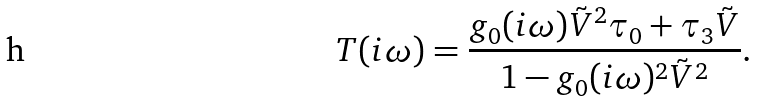Convert formula to latex. <formula><loc_0><loc_0><loc_500><loc_500>T ( i \omega ) = \frac { g _ { 0 } ( i \omega ) \tilde { V } ^ { 2 } \tau _ { 0 } + \tau _ { 3 } \tilde { V } } { 1 - g _ { 0 } ( i \omega ) ^ { 2 } \tilde { V } ^ { 2 } } .</formula> 